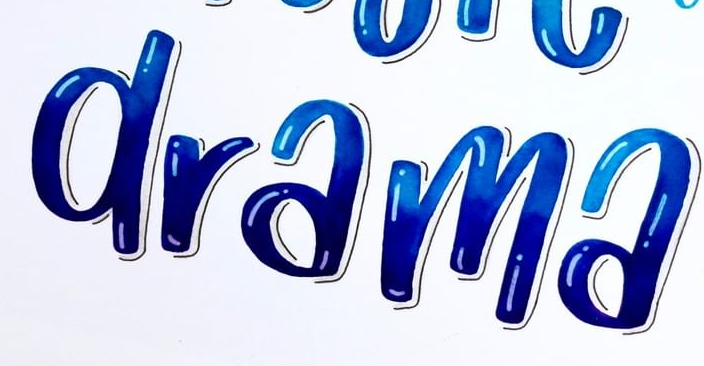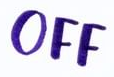Read the text from these images in sequence, separated by a semicolon. drama; OFF 